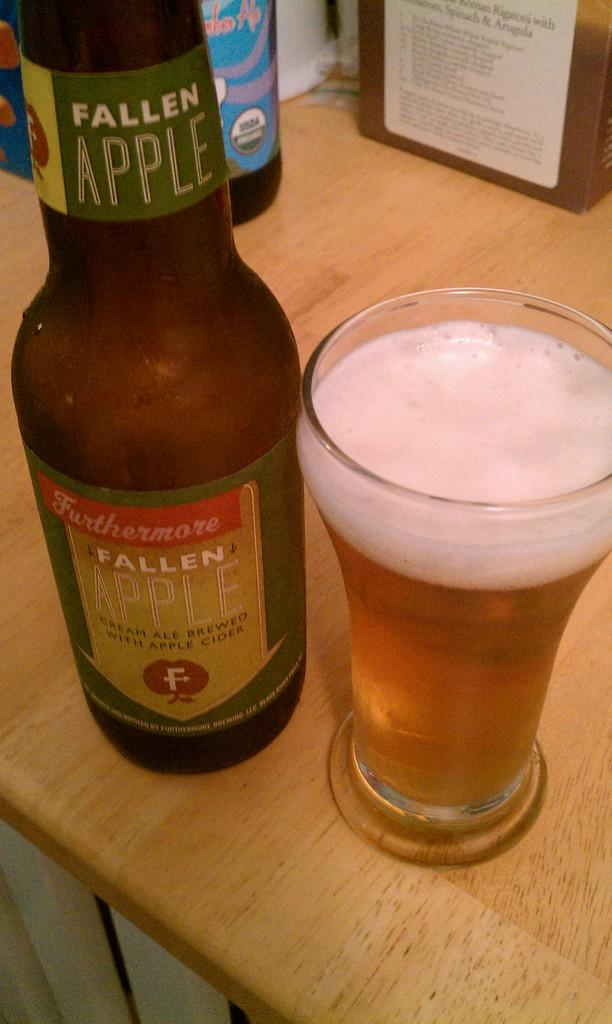<image>
Give a short and clear explanation of the subsequent image. Glass of beer with an apple on the label with an F on it. 